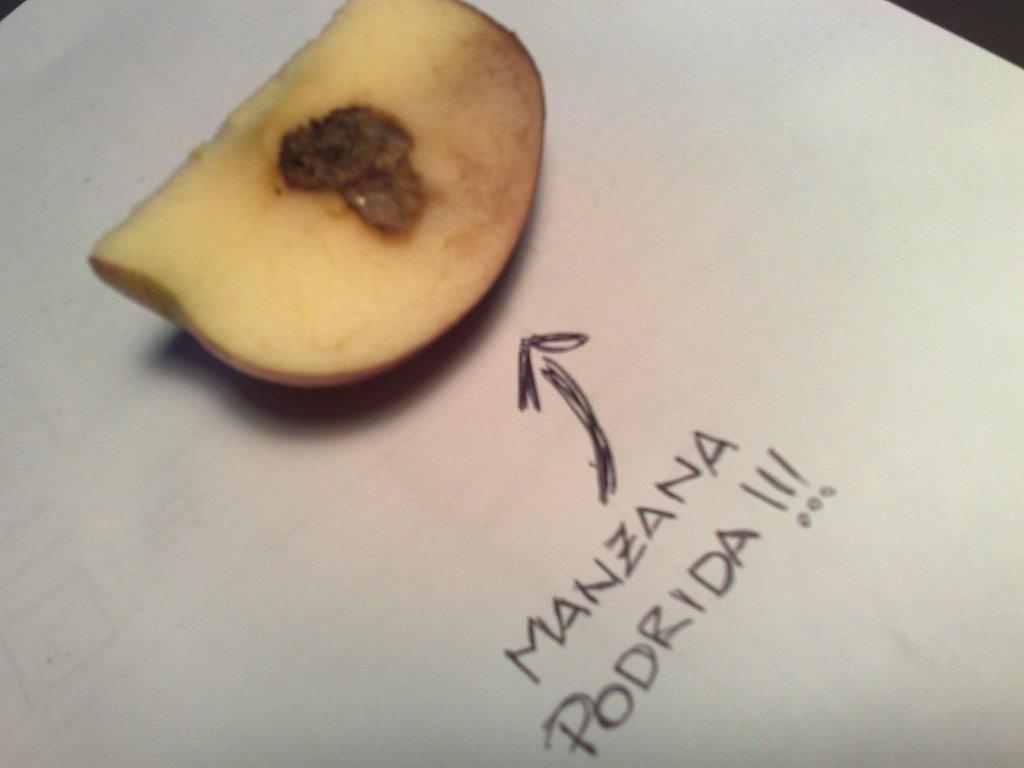What is the main subject of the image? The main subject of the image is an apple slice. Where is the apple slice located? The apple slice is placed on a paper. What else can be seen on the paper? There is text written on the paper beside the apple slice. How many kisses can be seen on the apple slice in the image? There are no kisses present on the apple slice in the image. What type of cheese is placed next to the apple slice in the image? There is no cheese present in the image; only an apple slice and text on a paper are visible. 